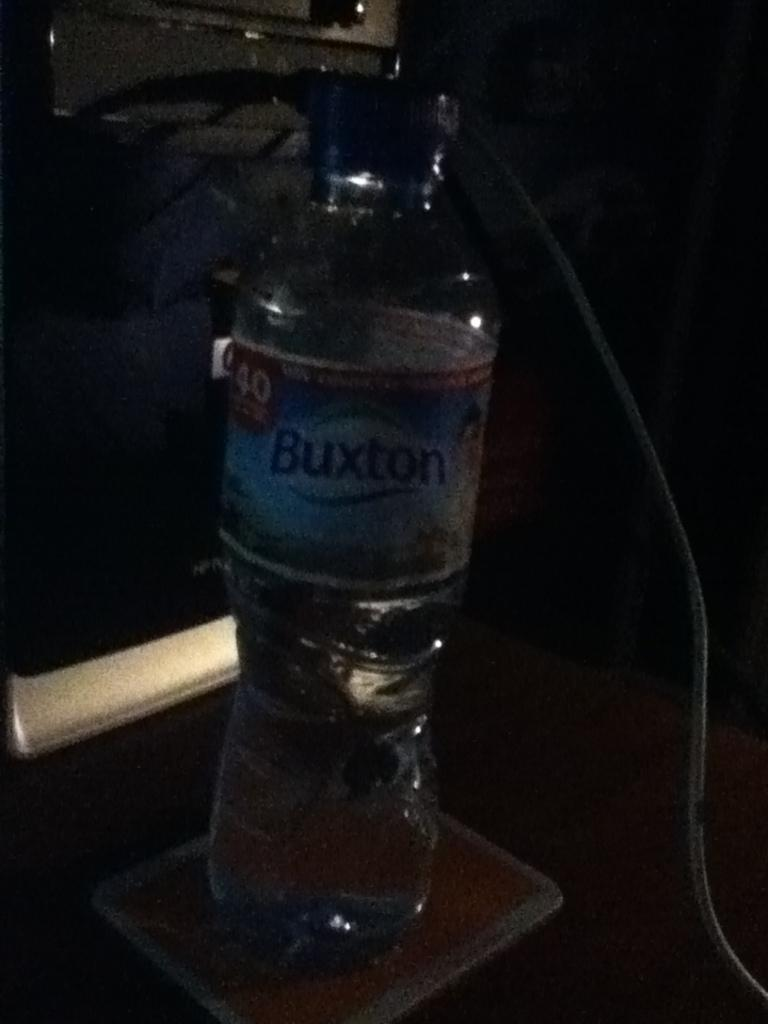What object can be seen in the image? There is a bottle in the image. What type of shade is provided by the bottle in the image? There is no shade provided by the bottle in the image, as it is a single object and does not create any shade. 